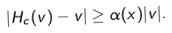Convert formula to latex. <formula><loc_0><loc_0><loc_500><loc_500>| H _ { c } ( v ) - v | \geq \alpha ( x ) | v | .</formula> 